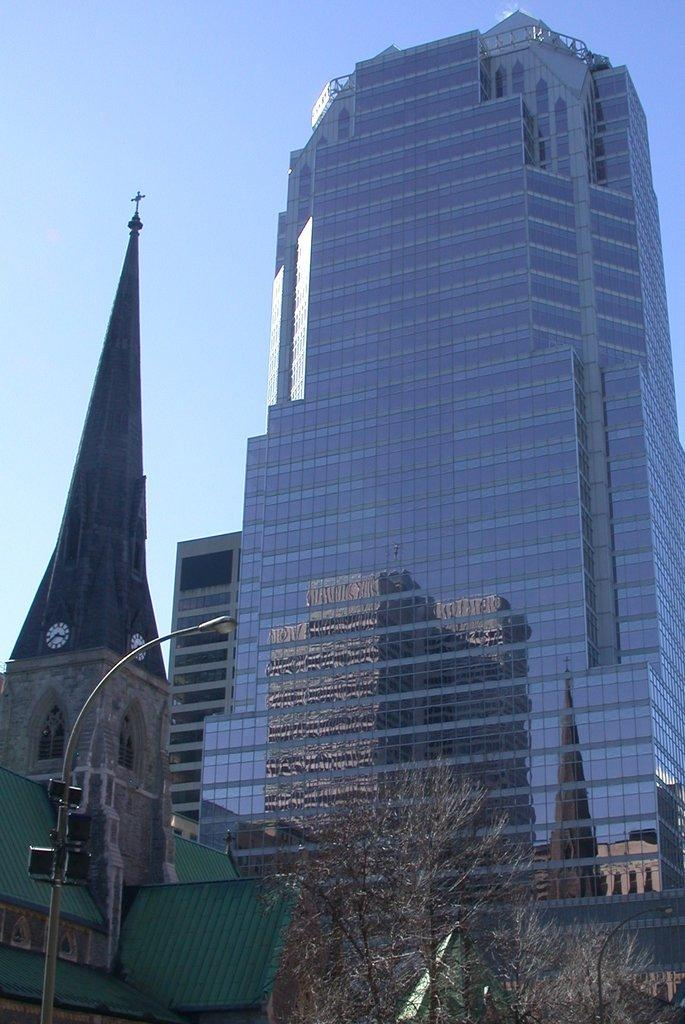What structure can be seen in the image? There is a light pole in the image. What type of natural elements are present in the image? There are trees in the image. What type of man-made structures can be seen in the image? There are buildings in the image. What is visible in the background of the image? The sky is visible in the background of the image. What type of breakfast is being served in the image? There is no breakfast present in the image; it features a light pole, trees, buildings, and the sky. How many potatoes can be seen in the image? There are no potatoes present in the image. 